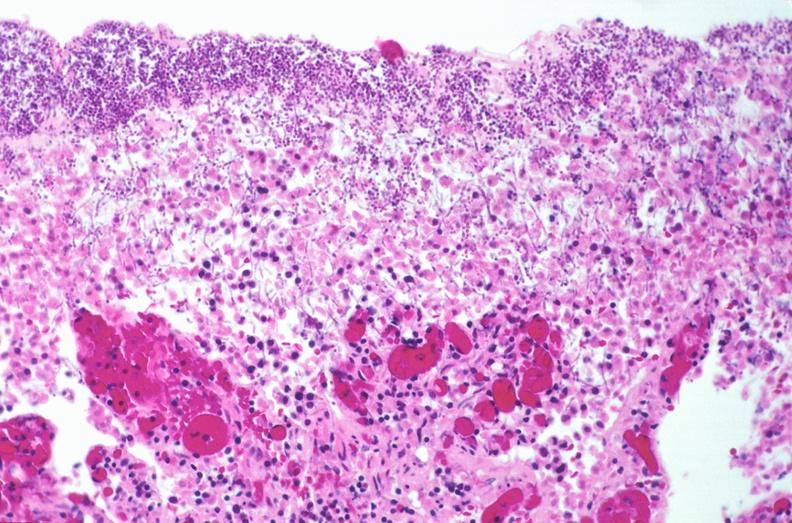what does this image show?
Answer the question using a single word or phrase. Duodenum 